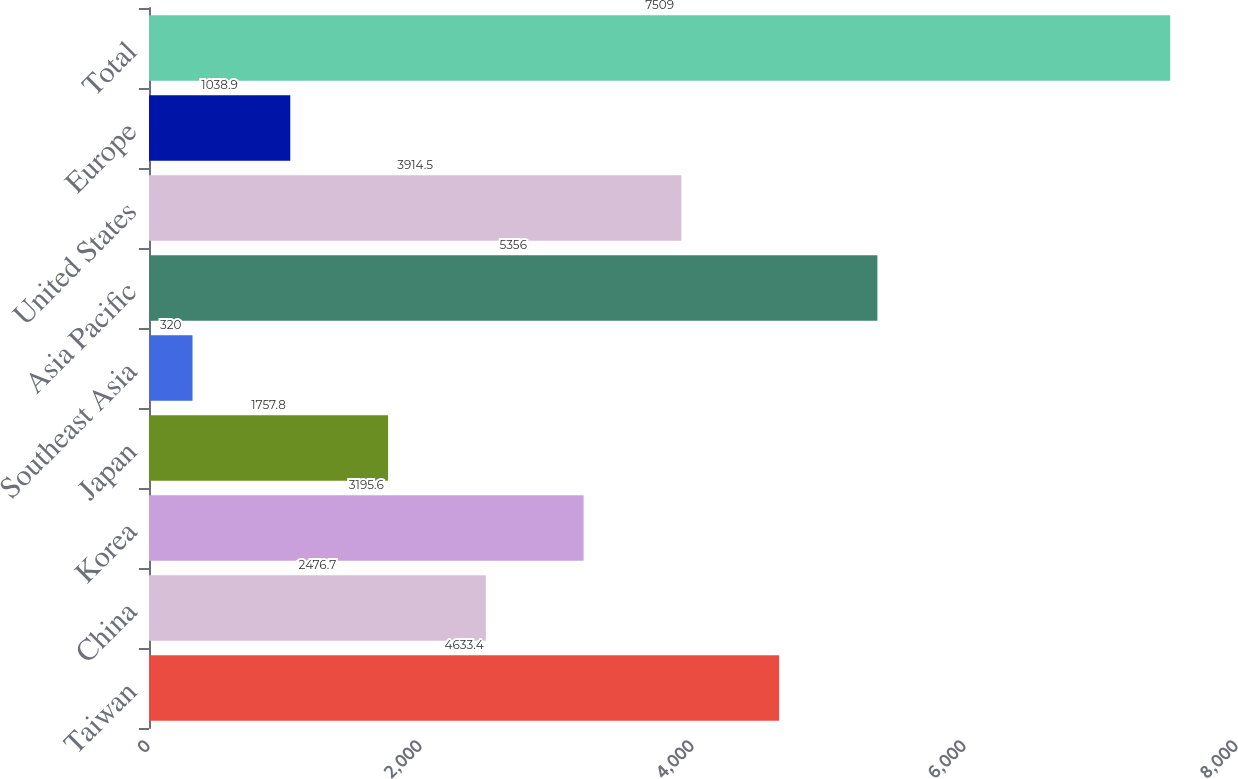<chart> <loc_0><loc_0><loc_500><loc_500><bar_chart><fcel>Taiwan<fcel>China<fcel>Korea<fcel>Japan<fcel>Southeast Asia<fcel>Asia Pacific<fcel>United States<fcel>Europe<fcel>Total<nl><fcel>4633.4<fcel>2476.7<fcel>3195.6<fcel>1757.8<fcel>320<fcel>5356<fcel>3914.5<fcel>1038.9<fcel>7509<nl></chart> 